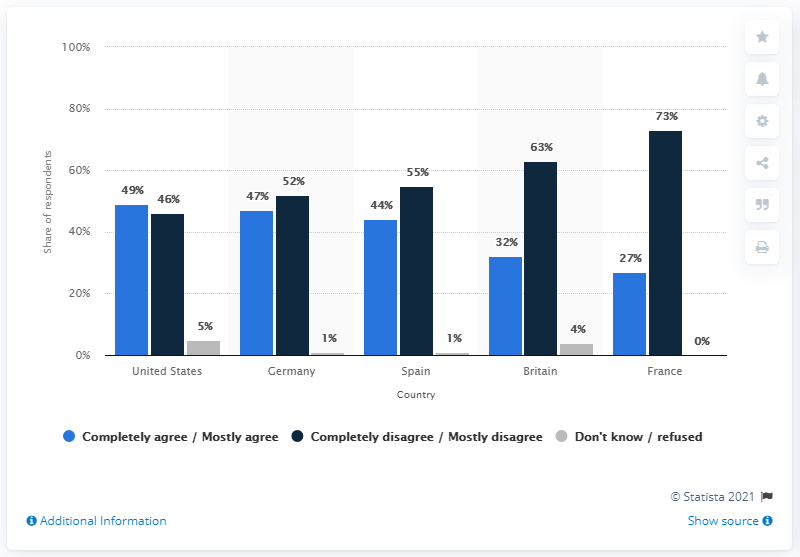Indicate a few pertinent items in this graphic. The average of all the dark blue bars is 57.8. I'm sorry, but I'm not sure what you mean by "How many countries data compared in the chart? 5.." Please provide more context or clarify your question. 